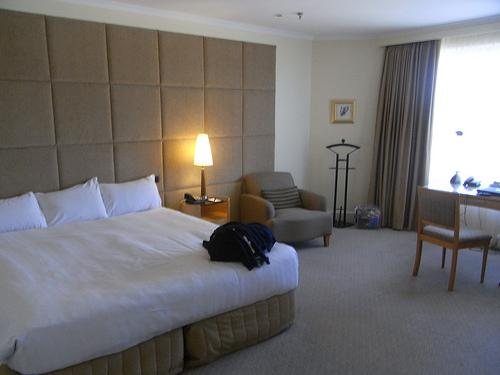Give a brief summary of the scene in the image, including key elements. The scene includes a bedroom with a king-sized bed, three pillows on it, a wooden desk with a computer and phone, a wooden chair on a carpet, a brown lounge chair with a pillow, and a black metal clothes stand, all complemented with a gold-framed picture on the wall and large brown curtains. Count the number of white pillows on the bed. There are three white pillows on the bed. What kind of object is mounted on the ceiling? A water sprinkler unit is mounted on the white ceiling. How many pillows are on the bed and the chair combined? There are four pillows in total: three on the bed and one on the chair. What are the contents on the desk? The desk has a computer and a phone on it. Mention the distinctive features of the chair in the room. The chair has a fabric seat and back, wooden frame, and is located on the carpet. Briefly describe the artwork on the wall. The artwork is a gold-framed picture hanging on a white wall. What is the color and material of the clothes stand in the image? The clothes stand is black and made of metal. Identify the color of the curtains in the room. The curtains are brown. Point out the main pieces of furniture in the room. The main pieces of furniture are a king-sized bed, a wooden chair, a desk, and a brown lounge chair. List down the items found on the bedside table. lamp, phone, other item Locate any metal dress rack in the image. The metal dress rack is present at coordinates X:316 Y:133 with a width of 49 and a height of 49. Are there any anomalies or unusual objects in the image? No, there are no anomalies or unusual objects. Search for a gold framed picture in the image. The gold framed picture is hanging on a white wall at X:325 Y:95 width:34 and height:34. Is there any sunlight coming into the room through a window? Yes, sun is shining through the window. Find the area of the image where the curtains are hanging. The curtains are hanging at X:363 Y:34 with a width of 79 and a height of 79. What type of wall decoration is present? There is a gold framed picture hanging on a white wall and brown fabric texture wall panels. Are there five white pillows on the bed instead of three? No, it's not mentioned in the image. What kind of chair is visible in the room? Fabric seat and back wooden chair on carpet. Identify the color of the carpet on the ground. The color of the carpet is gray. Determine the attributes of the curtains hanging in the image. The curtains are large, brown, and hang by a window covering. Describe the quality of the image in terms of clarity and resolution. The image has clear and high-resolution quality. How does the overall sentiment of the image look like? The image conveys a cozy, comfortable, and inviting sentiment. Evaluate the image for the presence of any anomaly. There are no anomalies present in the image. Is there any text or letterings visible in the image? No, there are no visible text or letterings. Inspect the image for any water sprinkler units. There is a water sprinkler unit on the white ceiling at coordinates X:292 Y:10 with a width of 16 and height of 16. Describe the interaction between the objects in the room. The objects in the room have a harmonious arrangement, creating a comfortable living space. Identify the types of flooring in the image. Carpet Briefly describe the bed in the image. The bed is a king-sized bed with white bed covering, tan bedskirt, and three white pillows.  Analyze the sentiment of the image. The image has a cozy and comfortable sentiment. 